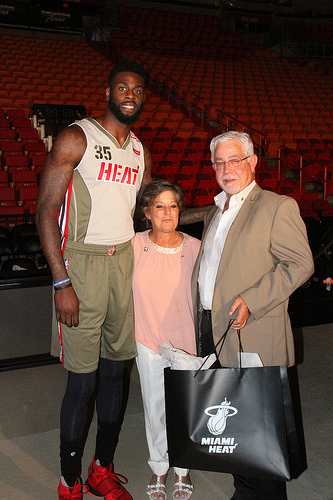<image>
Can you confirm if the woman is in front of the man? No. The woman is not in front of the man. The spatial positioning shows a different relationship between these objects. 